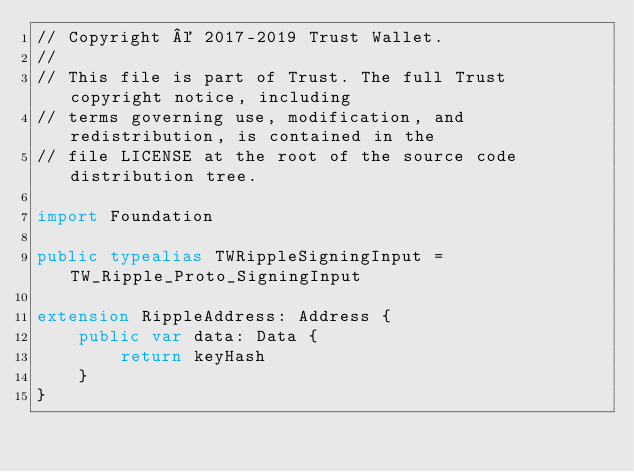Convert code to text. <code><loc_0><loc_0><loc_500><loc_500><_Swift_>// Copyright © 2017-2019 Trust Wallet.
//
// This file is part of Trust. The full Trust copyright notice, including
// terms governing use, modification, and redistribution, is contained in the
// file LICENSE at the root of the source code distribution tree.

import Foundation

public typealias TWRippleSigningInput = TW_Ripple_Proto_SigningInput

extension RippleAddress: Address {
    public var data: Data {
        return keyHash
    }
}
</code> 